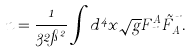<formula> <loc_0><loc_0><loc_500><loc_500>n = \frac { 1 } { 3 2 \pi ^ { 2 } } \int d ^ { 4 } x \sqrt { g } F ^ { A } _ { \mu \nu } \tilde { F } _ { A } ^ { \mu \nu } .</formula> 